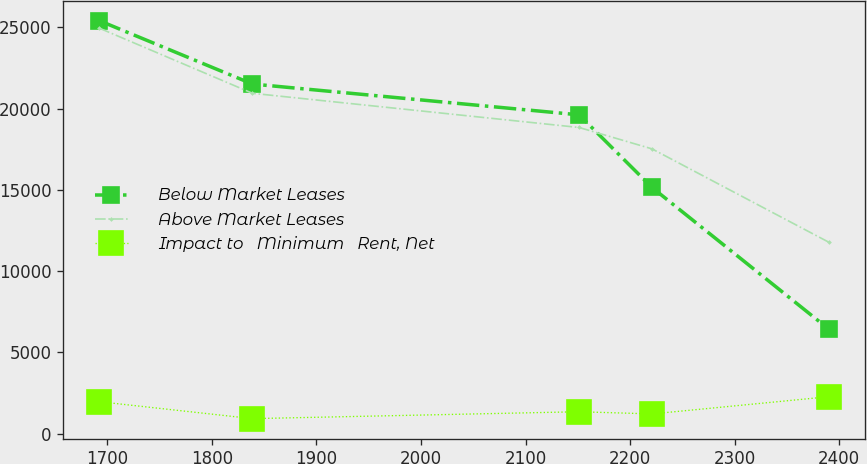<chart> <loc_0><loc_0><loc_500><loc_500><line_chart><ecel><fcel>Below Market Leases<fcel>Above Market Leases<fcel>Impact to   Minimum   Rent, Net<nl><fcel>1692.52<fcel>25412.5<fcel>24951.9<fcel>1965.66<nl><fcel>1838.83<fcel>21517.2<fcel>20946.5<fcel>925.36<nl><fcel>2151.21<fcel>19620.5<fcel>18842.5<fcel>1349.85<nl><fcel>2220.93<fcel>15149.9<fcel>17526.4<fcel>1215.08<nl><fcel>2389.74<fcel>6444.7<fcel>11790.7<fcel>2273.06<nl></chart> 